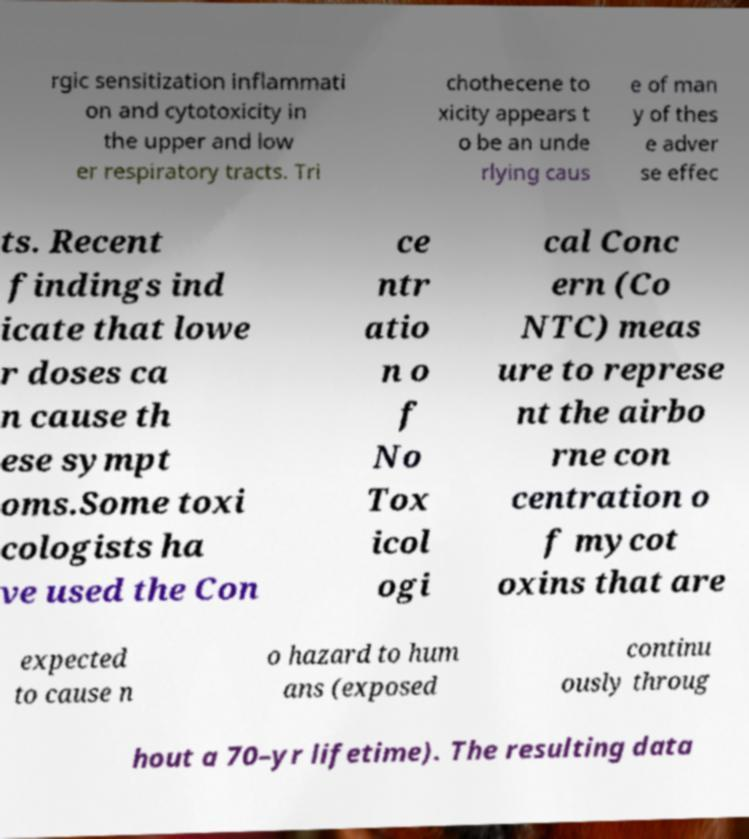What messages or text are displayed in this image? I need them in a readable, typed format. rgic sensitization inflammati on and cytotoxicity in the upper and low er respiratory tracts. Tri chothecene to xicity appears t o be an unde rlying caus e of man y of thes e adver se effec ts. Recent findings ind icate that lowe r doses ca n cause th ese sympt oms.Some toxi cologists ha ve used the Con ce ntr atio n o f No Tox icol ogi cal Conc ern (Co NTC) meas ure to represe nt the airbo rne con centration o f mycot oxins that are expected to cause n o hazard to hum ans (exposed continu ously throug hout a 70–yr lifetime). The resulting data 